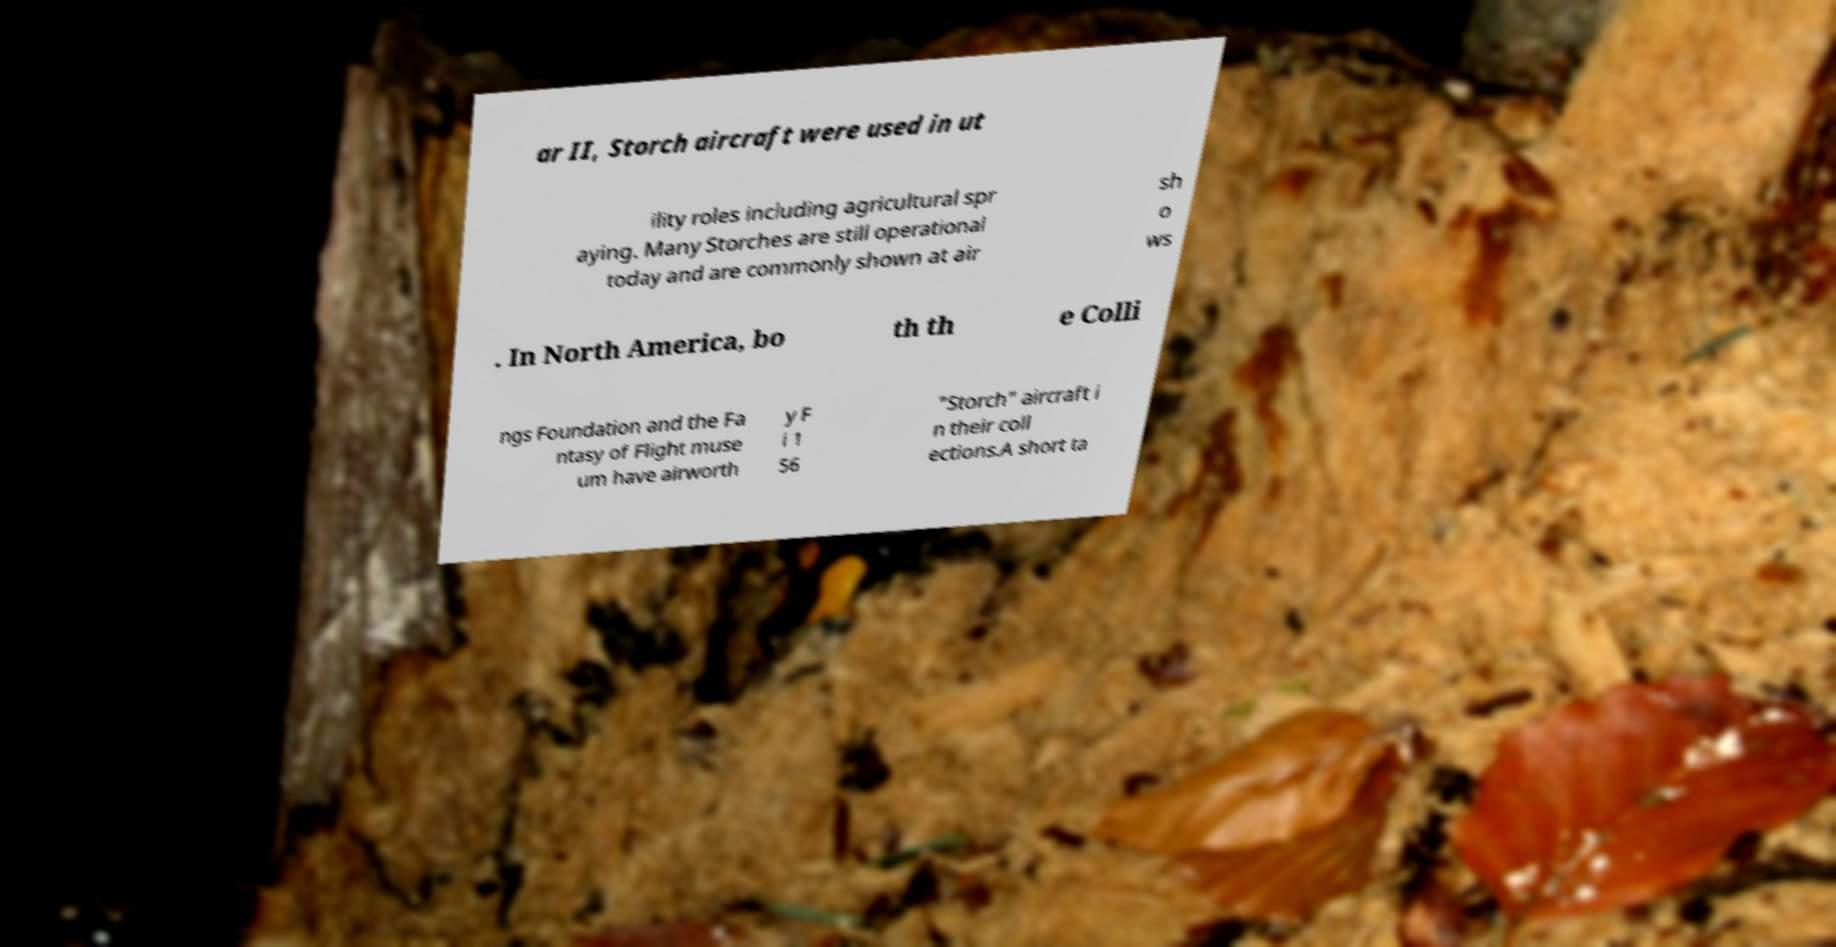What messages or text are displayed in this image? I need them in a readable, typed format. ar II, Storch aircraft were used in ut ility roles including agricultural spr aying. Many Storches are still operational today and are commonly shown at air sh o ws . In North America, bo th th e Colli ngs Foundation and the Fa ntasy of Flight muse um have airworth y F i 1 56 "Storch" aircraft i n their coll ections.A short ta 